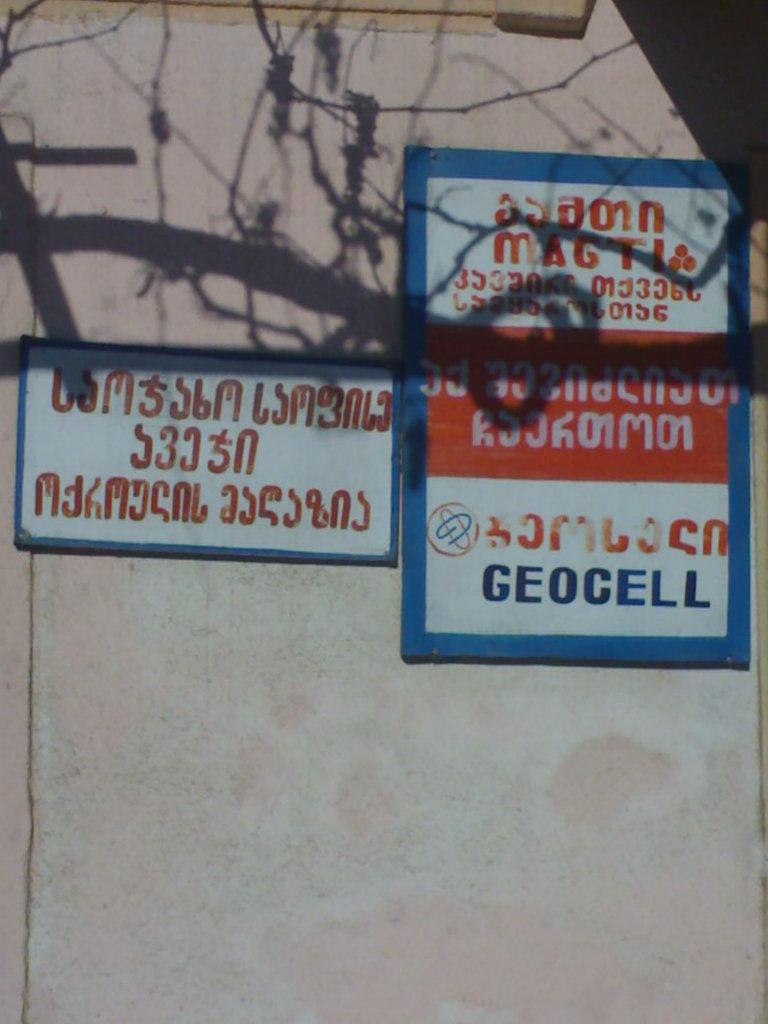<image>
Describe the image concisely. Two signs on a wall outdoors with one saying "Geocell". 